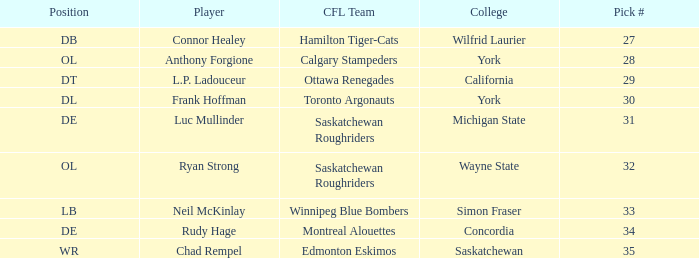What is the Pick # for Ryan Strong? 32.0. 